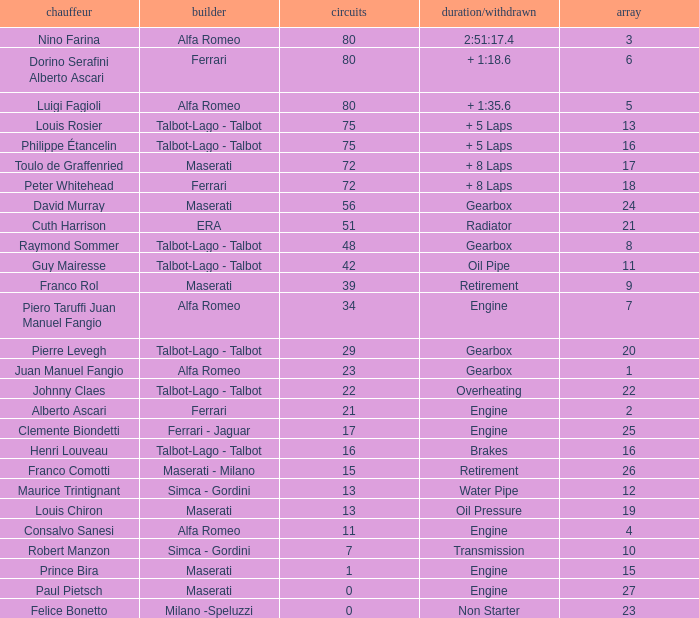When the driver is Juan Manuel Fangio and laps is less than 39, what is the highest grid? 1.0. 